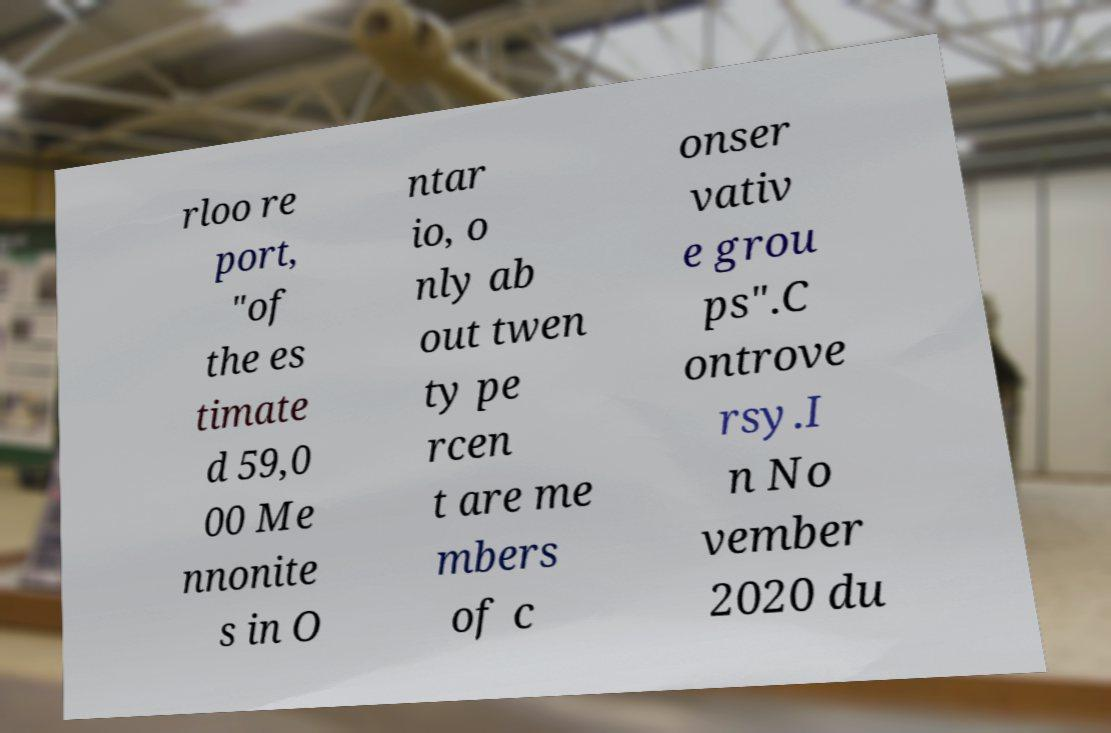Can you accurately transcribe the text from the provided image for me? rloo re port, "of the es timate d 59,0 00 Me nnonite s in O ntar io, o nly ab out twen ty pe rcen t are me mbers of c onser vativ e grou ps".C ontrove rsy.I n No vember 2020 du 